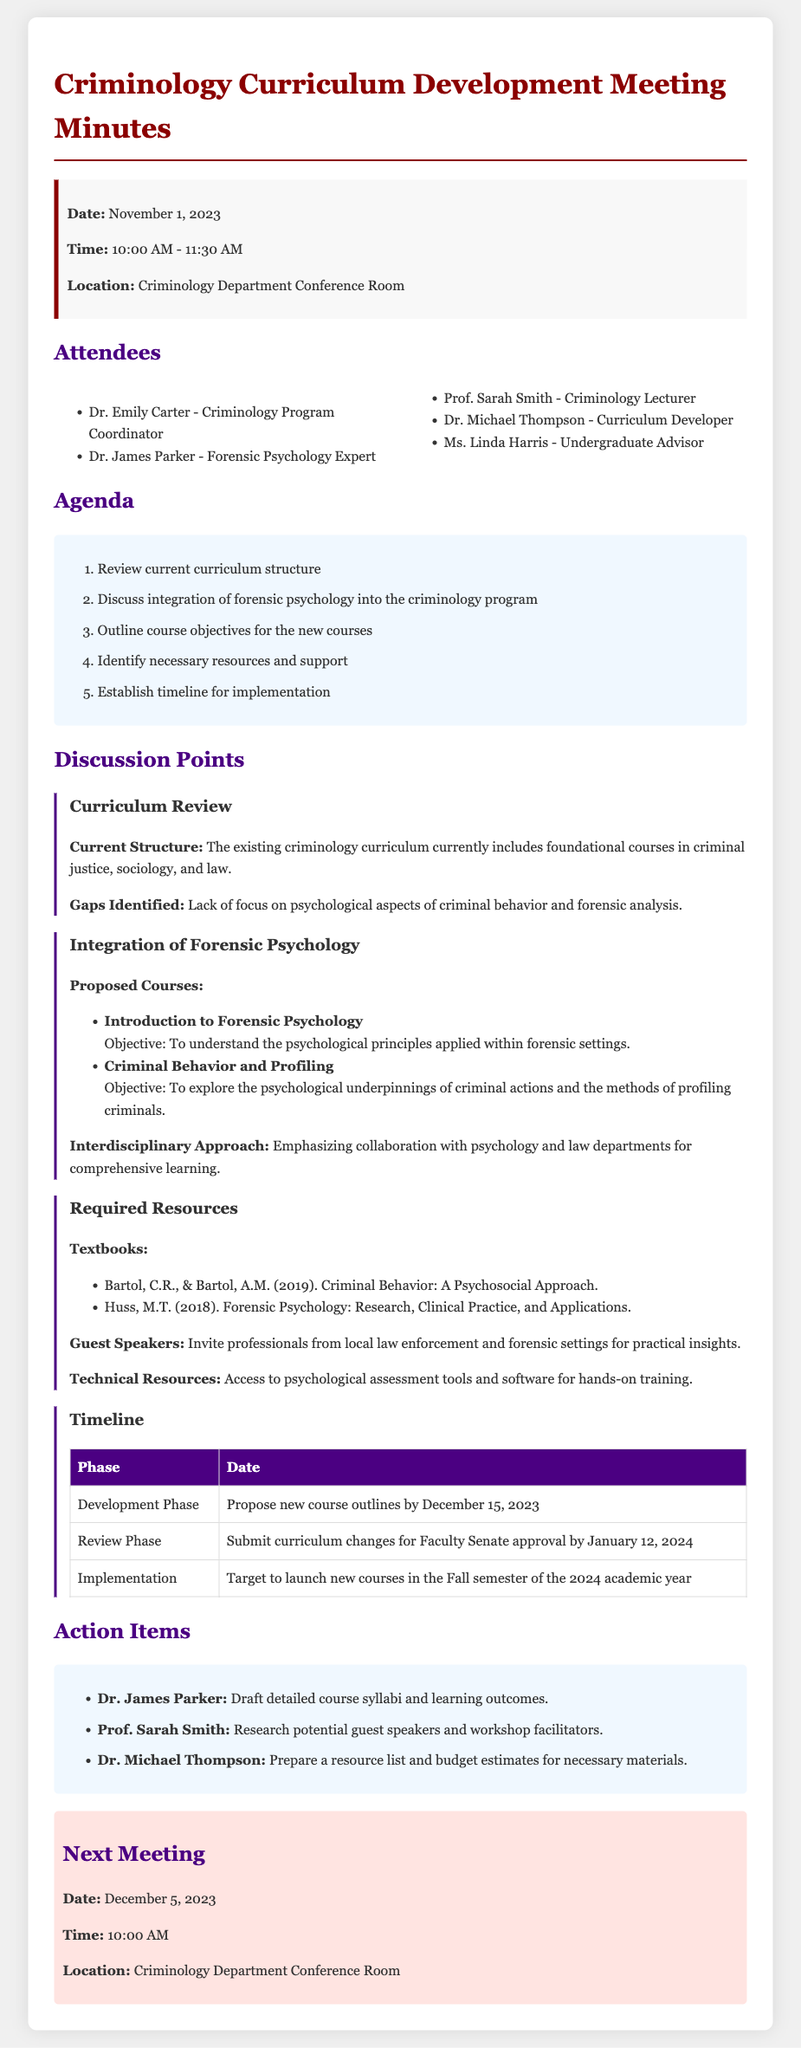What is the date of the meeting? The date of the meeting is stated clearly in the meeting info section.
Answer: November 1, 2023 Who is the Criminology Program Coordinator? The document lists the attendees and their roles, including the Criminology Program Coordinator.
Answer: Dr. Emily Carter What is one proposed course in forensic psychology? The discussion points include proposed courses with their names provided in the document.
Answer: Introduction to Forensic Psychology What is the objective of the course "Criminal Behavior and Profiling"? The objectives of the new courses are outlined in the discussion points, specifying what students will learn.
Answer: To explore the psychological underpinnings of criminal actions and the methods of profiling criminals When is the target implementation date for the new courses? This information is found in the timeline section of the document detailing the phases of implementation.
Answer: Fall semester of the 2024 academic year What resource type is mentioned for guest speakers? The required resources section mentions various types of resources including guest speakers for insights.
Answer: Professionals from local law enforcement and forensic settings Who is responsible for drafting the course syllabi? The action items section assigns specific tasks to attendees, identifying who is responsible for each.
Answer: Dr. James Parker What is the next meeting date? The next meeting date is specified in the meeting minutes, providing future meeting information.
Answer: December 5, 2023 